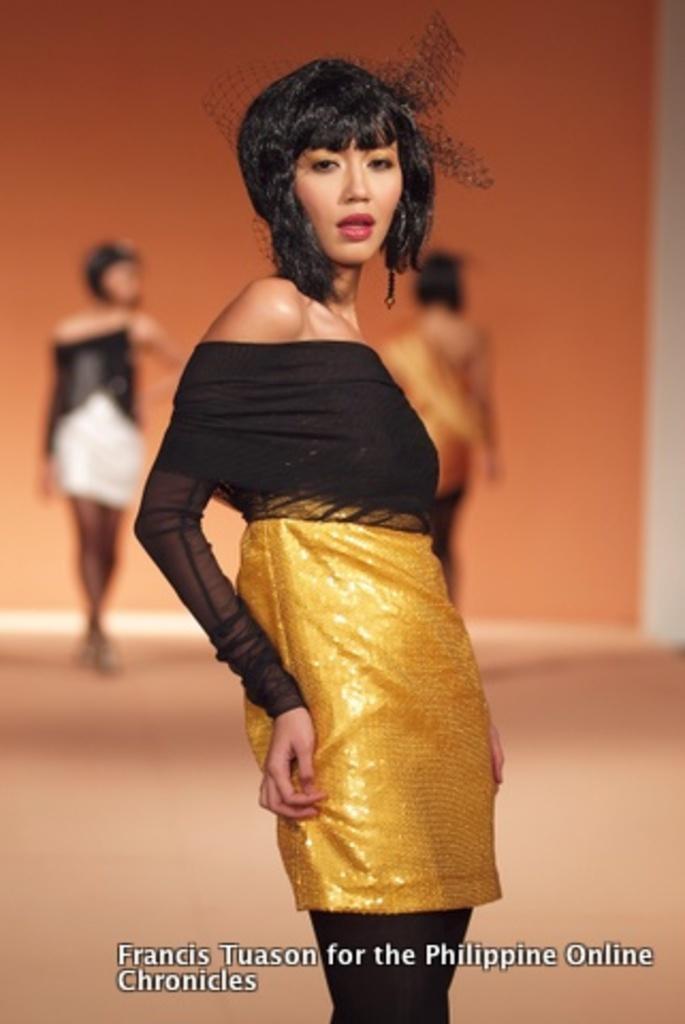In one or two sentences, can you explain what this image depicts? In this image we can see a woman. In the background we can see two persons are standing on the floor and there is a wall. At the bottom of the image we can see something is written on it. 